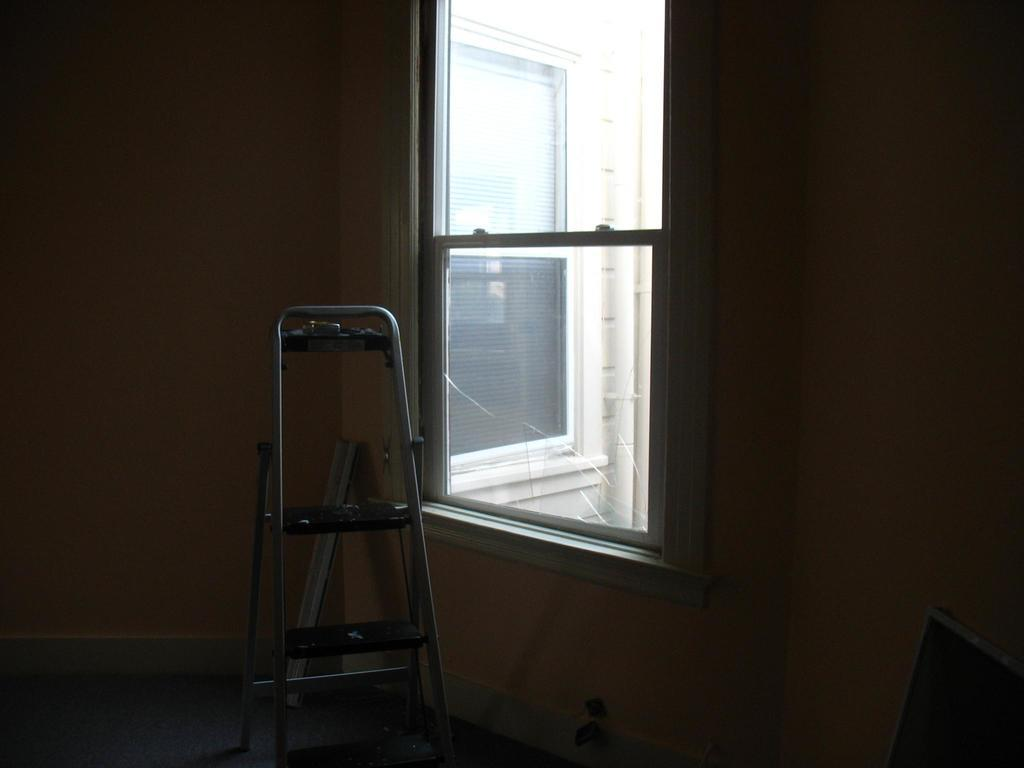What is the main object in the image? There is a ladder in the image. What is the ladder leaning against? The ladder is leaning against a wall in the image. What can be seen through the first window? Another window is visible through the first window in the image. What else can be seen through the first window? There are 2 pipes visible through the first window in the image. How many friends are visible in the image? There are no friends visible in the image; it only features a ladder, a wall, a window, another window, and 2 pipes. 